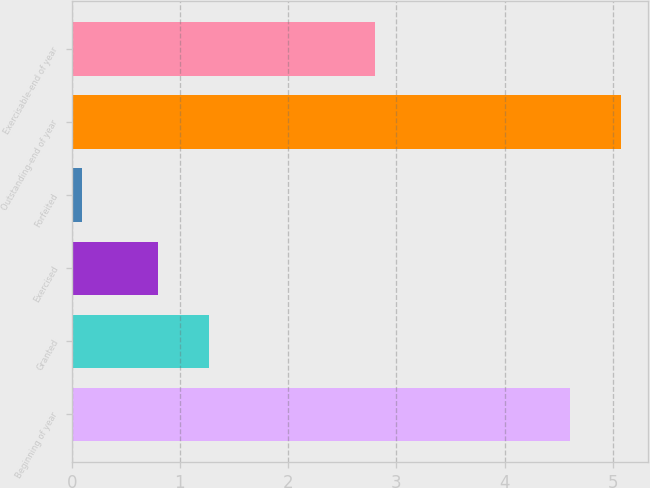<chart> <loc_0><loc_0><loc_500><loc_500><bar_chart><fcel>Beginning of year<fcel>Granted<fcel>Exercised<fcel>Forfeited<fcel>Outstanding-end of year<fcel>Exercisable-end of year<nl><fcel>4.6<fcel>1.27<fcel>0.8<fcel>0.1<fcel>5.07<fcel>2.8<nl></chart> 